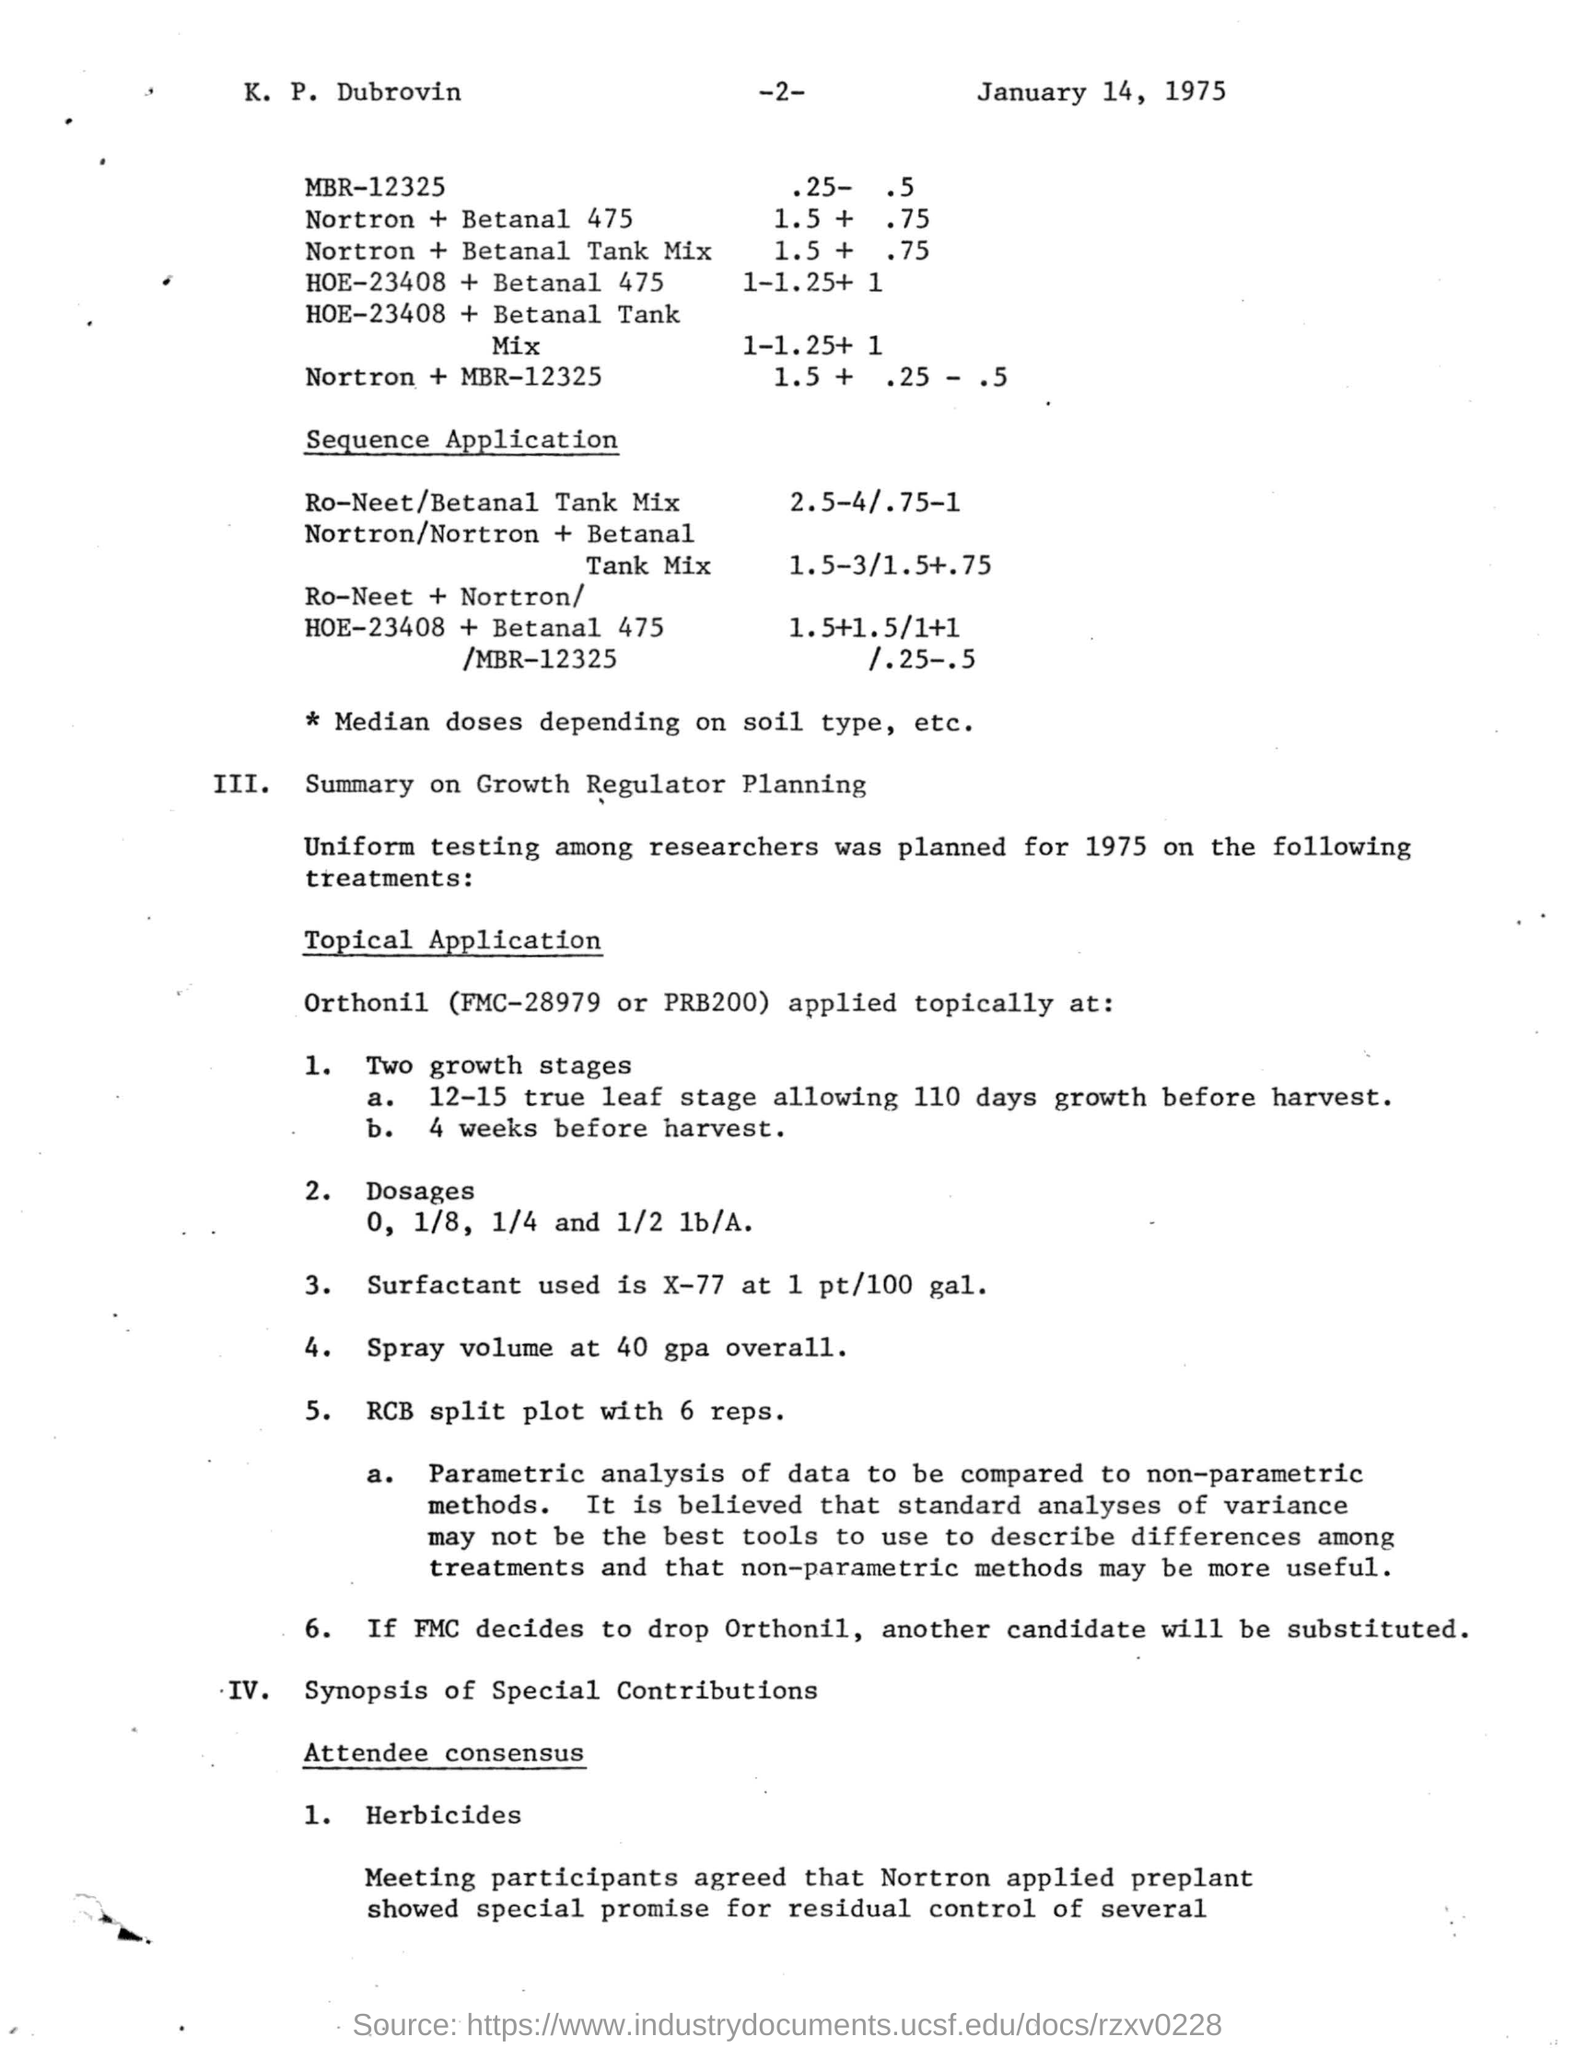What is the date mentioned in the given page ?
Your response must be concise. January 14, 1975. 